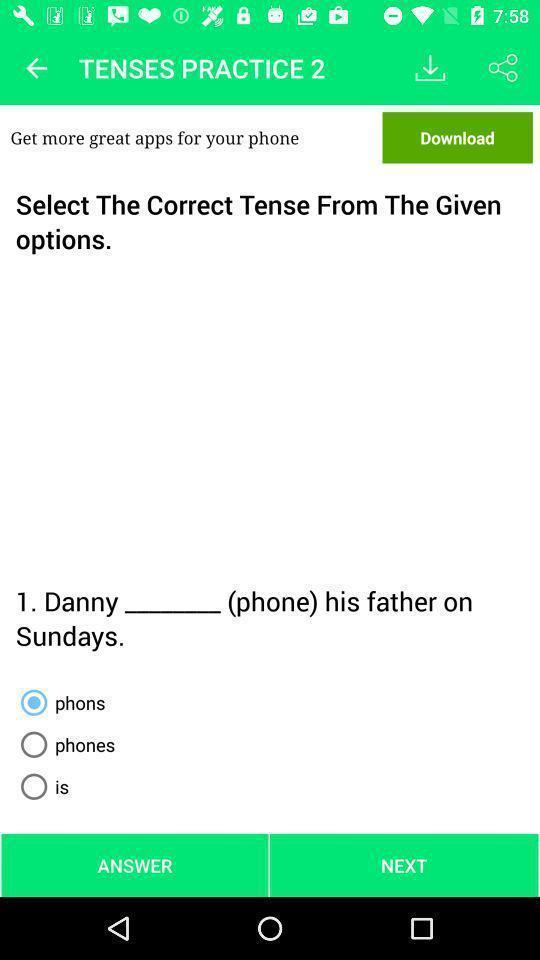Summarize the information in this screenshot. Select the correct tense from the given options. 